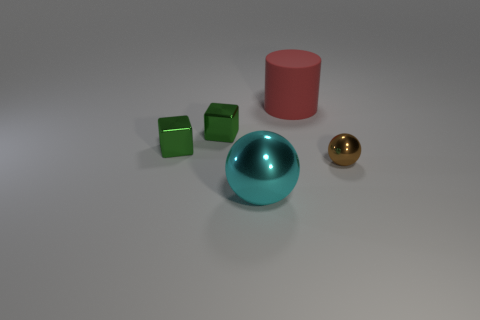How does the arrangement of these objects affect the composition of the image? The objects are positioned in a balanced yet asymmetrical arrangement, creating a dynamic visual interest. The use of space and the varying sizes draw the eye through the image, while the contrasting colors add depth and emphasize the three-dimensional forms. 